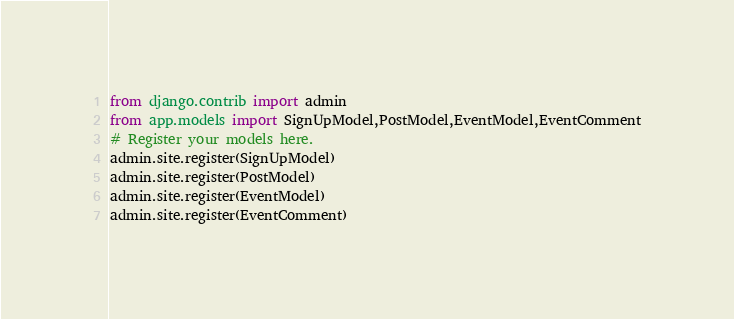Convert code to text. <code><loc_0><loc_0><loc_500><loc_500><_Python_>from django.contrib import admin
from app.models import SignUpModel,PostModel,EventModel,EventComment
# Register your models here.
admin.site.register(SignUpModel)
admin.site.register(PostModel)
admin.site.register(EventModel)
admin.site.register(EventComment)
</code> 